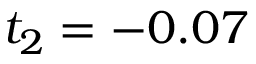Convert formula to latex. <formula><loc_0><loc_0><loc_500><loc_500>t _ { 2 } = - 0 . 0 7</formula> 